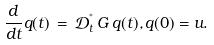Convert formula to latex. <formula><loc_0><loc_0><loc_500><loc_500>\frac { d } { d t } q ( t ) \, = \, \mathcal { D } _ { t } ^ { ^ { * } } \, G \, q ( t ) , q ( 0 ) = u .</formula> 